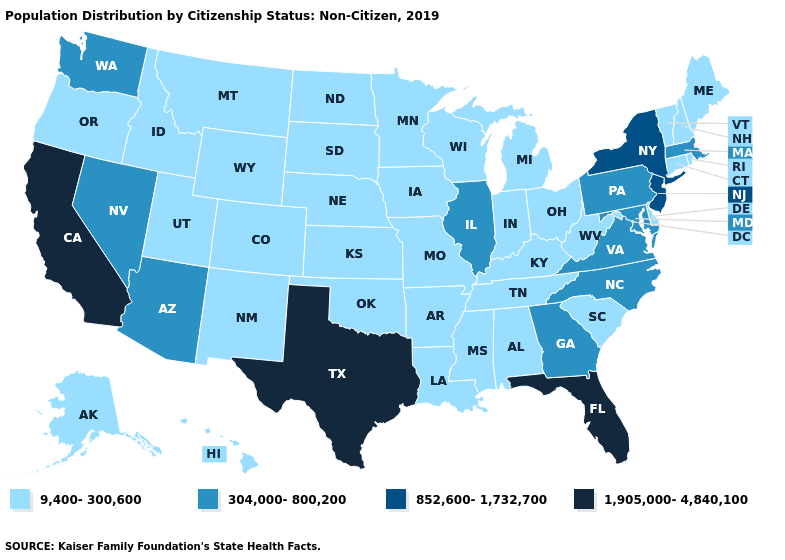Does Georgia have the lowest value in the USA?
Quick response, please. No. Does Pennsylvania have the same value as Utah?
Short answer required. No. What is the highest value in the USA?
Keep it brief. 1,905,000-4,840,100. What is the highest value in the USA?
Be succinct. 1,905,000-4,840,100. Does Oregon have the highest value in the West?
Quick response, please. No. What is the highest value in states that border Vermont?
Answer briefly. 852,600-1,732,700. Among the states that border Wyoming , which have the lowest value?
Keep it brief. Colorado, Idaho, Montana, Nebraska, South Dakota, Utah. What is the value of Georgia?
Concise answer only. 304,000-800,200. What is the value of South Carolina?
Give a very brief answer. 9,400-300,600. Which states have the lowest value in the USA?
Write a very short answer. Alabama, Alaska, Arkansas, Colorado, Connecticut, Delaware, Hawaii, Idaho, Indiana, Iowa, Kansas, Kentucky, Louisiana, Maine, Michigan, Minnesota, Mississippi, Missouri, Montana, Nebraska, New Hampshire, New Mexico, North Dakota, Ohio, Oklahoma, Oregon, Rhode Island, South Carolina, South Dakota, Tennessee, Utah, Vermont, West Virginia, Wisconsin, Wyoming. Does Ohio have a lower value than Wyoming?
Be succinct. No. What is the lowest value in states that border Florida?
Quick response, please. 9,400-300,600. Which states have the highest value in the USA?
Short answer required. California, Florida, Texas. Does California have the highest value in the USA?
Answer briefly. Yes. What is the highest value in the USA?
Give a very brief answer. 1,905,000-4,840,100. 